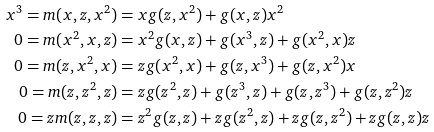<formula> <loc_0><loc_0><loc_500><loc_500>x ^ { 3 } = m ( x , z , x ^ { 2 } ) & = x g ( z , x ^ { 2 } ) + g ( x , z ) x ^ { 2 } \\ 0 = m ( x ^ { 2 } , x , z ) & = x ^ { 2 } g ( x , z ) + g ( x ^ { 3 } , z ) + g ( x ^ { 2 } , x ) z \\ 0 = m ( z , x ^ { 2 } , x ) & = z g ( x ^ { 2 } , x ) + g ( z , x ^ { 3 } ) + g ( z , x ^ { 2 } ) x \\ 0 = m ( z , z ^ { 2 } , z ) & = z g ( z ^ { 2 } , z ) + g ( z ^ { 3 } , z ) + g ( z , z ^ { 3 } ) + g ( z , z ^ { 2 } ) z \\ 0 = z m ( z , z , z ) & = z ^ { 2 } g ( z , z ) + z g ( z ^ { 2 } , z ) + z g ( z , z ^ { 2 } ) + z g ( z , z ) z</formula> 